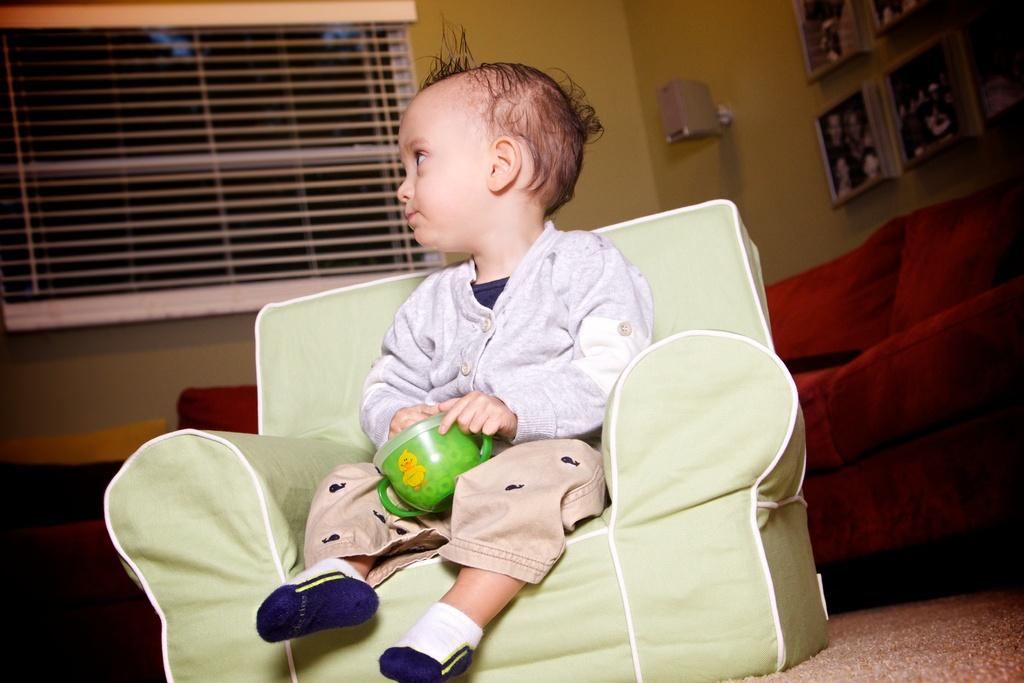What is the boy in the image doing? The boy is sitting on a chair in the image. What is the boy holding in the image? The boy is holding a cup in the image. What furniture is located behind the chair? There is a sofa behind the chair in the image. What is beside the sofa? There is a lamp beside the sofa in the image. What decorations are hanging on the wall? There are photo frames hanging on the wall in the image. What type of icicle can be seen hanging from the lamp in the image? There is no icicle present in the image; it is indoors and not cold enough for icicles to form. 